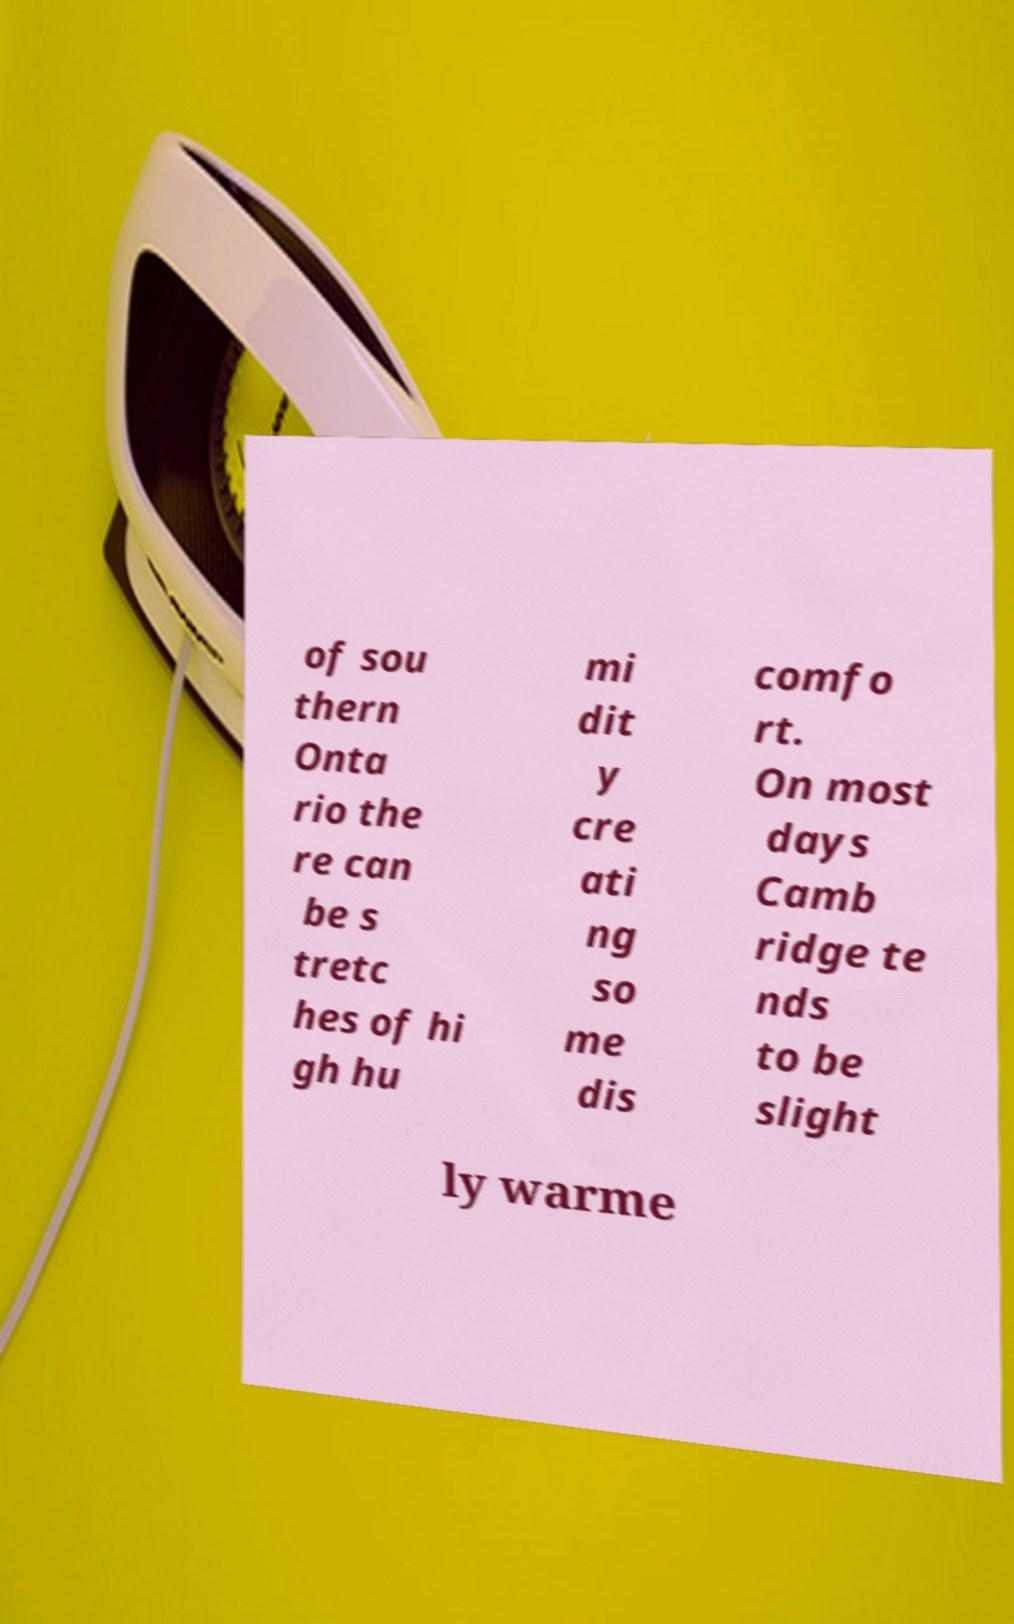Please identify and transcribe the text found in this image. of sou thern Onta rio the re can be s tretc hes of hi gh hu mi dit y cre ati ng so me dis comfo rt. On most days Camb ridge te nds to be slight ly warme 